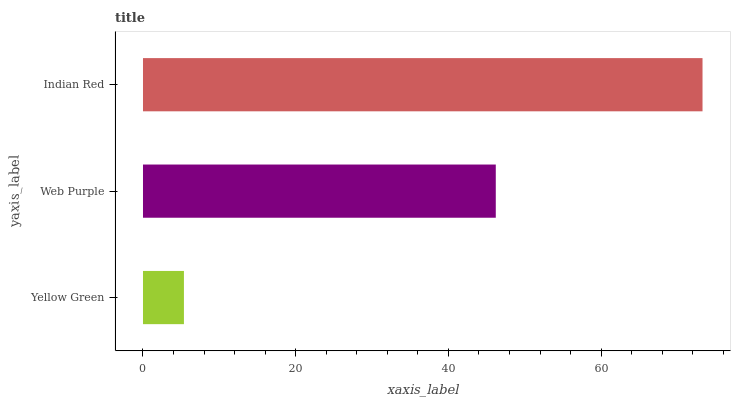Is Yellow Green the minimum?
Answer yes or no. Yes. Is Indian Red the maximum?
Answer yes or no. Yes. Is Web Purple the minimum?
Answer yes or no. No. Is Web Purple the maximum?
Answer yes or no. No. Is Web Purple greater than Yellow Green?
Answer yes or no. Yes. Is Yellow Green less than Web Purple?
Answer yes or no. Yes. Is Yellow Green greater than Web Purple?
Answer yes or no. No. Is Web Purple less than Yellow Green?
Answer yes or no. No. Is Web Purple the high median?
Answer yes or no. Yes. Is Web Purple the low median?
Answer yes or no. Yes. Is Yellow Green the high median?
Answer yes or no. No. Is Yellow Green the low median?
Answer yes or no. No. 